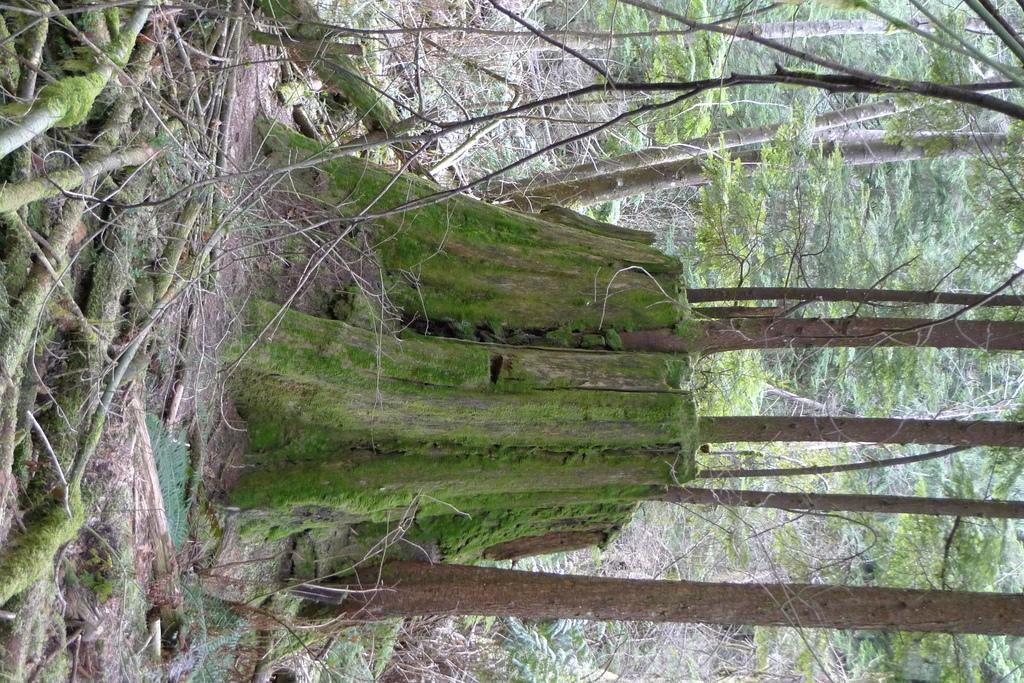How would you summarize this image in a sentence or two? Here in this picture on the ground we can see grass, plants and trees covered and in the middle we can see a wooden trunk present on the ground and we can also see roots and branches on the ground. 